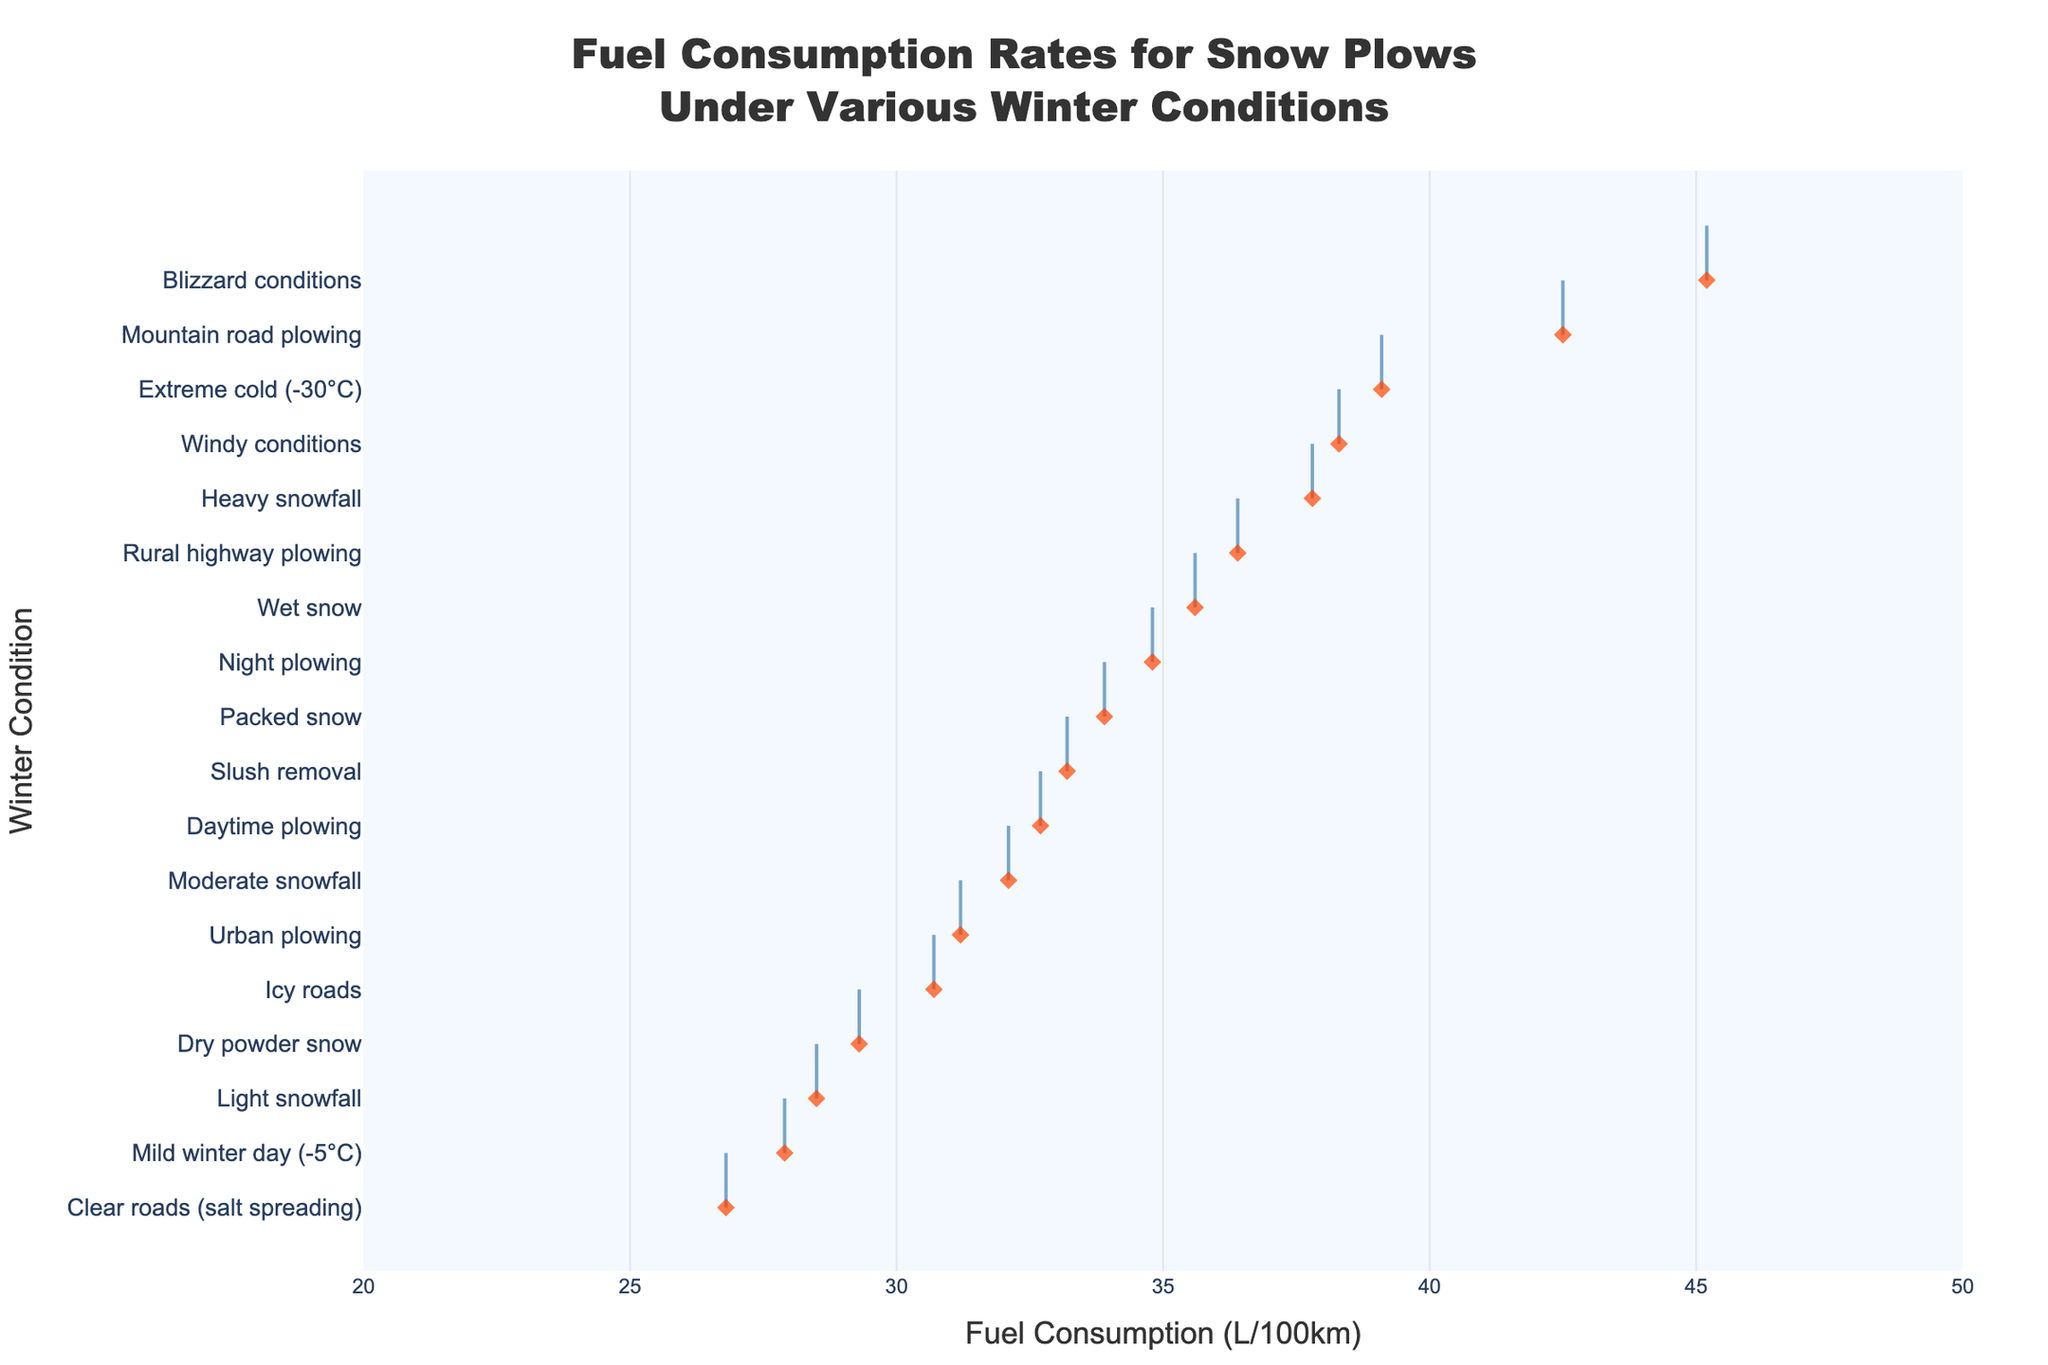What's the title of the plot? The title is typically displayed at the top of the plot panel. From the provided description, the title for our plot is mentioned under `title` in the `update_layout` function within the code.
Answer: Fuel Consumption Rates for Snow Plows Under Various Winter Conditions What is the range of fuel consumption shown on the x-axis? The x-axis range specified in the `update_layout` function shows the range from `20` to `50`, which can be identified by looking at the plot's x-axis tick marks.
Answer: 20 to 50 What is the winter condition with the highest fuel consumption rate? To find the maximum value, observe the rightmost data point on the plot and identify its corresponding condition on the y-axis.
Answer: Blizzard conditions Which winter condition has the lowest fuel consumption rate? To find the minimum value, observe the leftmost data point on the plot and identify its corresponding condition on the y-axis.
Answer: Clear roads (salt spreading) How many winter conditions are analyzed in total? Count the number of unique y-axis labels representing each winter condition analyzed in the plot.
Answer: 18 What's the average fuel consumption rate for the conditions displayed? Sum all the fuel consumption values and divide by the number of conditions: (28.5 + 32.1 + 37.8 + 45.2 + 30.7 + 33.9 + 35.6 + 29.3 + 31.2 + 36.4 + 42.5 + 34.8 + 32.7 + 39.1 + 27.9 + 38.3 + 26.8 + 33.2) / 18 = 34.29.
Answer: 34.29 What are the top three conditions with the highest fuel consumption rates? Identify the three rightmost points on the plot and list their corresponding conditions.
Answer: Blizzard conditions, Mountain road plowing, Extreme cold (-30°C) Is fuel consumption higher during day plowing or night plowing? Compare the x-axis values for 'Daytime plowing' and 'Night plowing': Daytime plowing is 32.7, Night plowing is 34.8.
Answer: Night plowing Which condition has a similar fuel consumption rate to 'Urban plowing'? Look for a point close to 31.2 (Urban plowing's rate). 'Moderate snowfall' is nearby at 32.1.
Answer: Moderate snowfall 